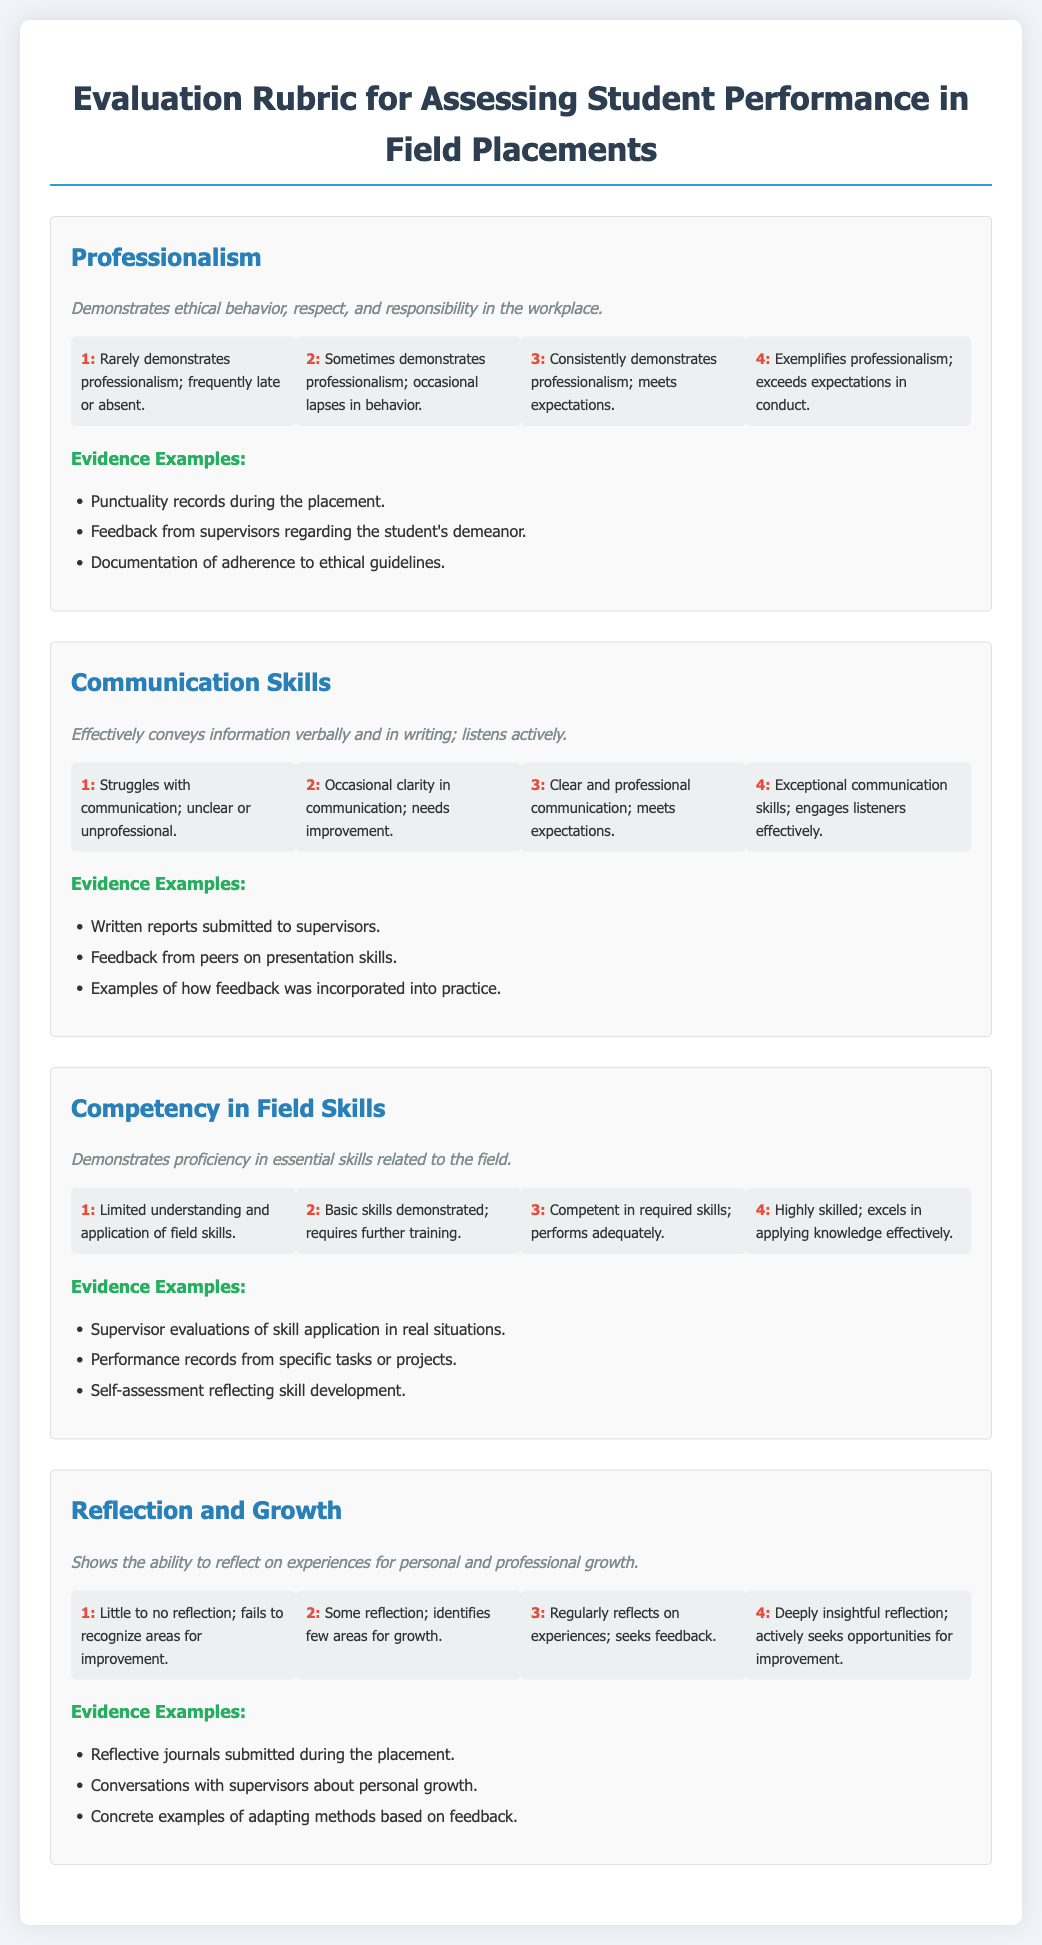What is the title of the document? The title is stated at the top of the document, clearly indicating the subject it covers.
Answer: Evaluation Rubric for Assessing Student Performance in Field Placements How many score ranges are there for each criterion? Each criterion in the document has four score ranges detailed in separate sections.
Answer: 4 What is the highest score for Professionalism? The highest score is indicated in the score range section for Professionalism.
Answer: 4 What skill is assessed under the criterion "Competency in Field Skills"? The main focus of this criterion is specified in its description, identifying the type of skills being measured.
Answer: Essential skills What does a score of 2 indicate in Communication Skills? This reflects the specific behavior and performance level expected for that score as described in the rubric.
Answer: Occasional clarity in communication; needs improvement Which criterion requires the student to submit reflective journals? The requirement is explicitly mentioned in the Evidence Examples section for a specific criterion relating to personal development.
Answer: Reflection and Growth What is an example of evidence for demonstrating professionalism? The document provides several examples of evidence that can support a score in this area.
Answer: Punctuality records during the placement What does a score of 1 in Reflection and Growth mean? The definition for this score describes the level of reflection expected from the student.
Answer: Little to no reflection; fails to recognize areas for improvement 